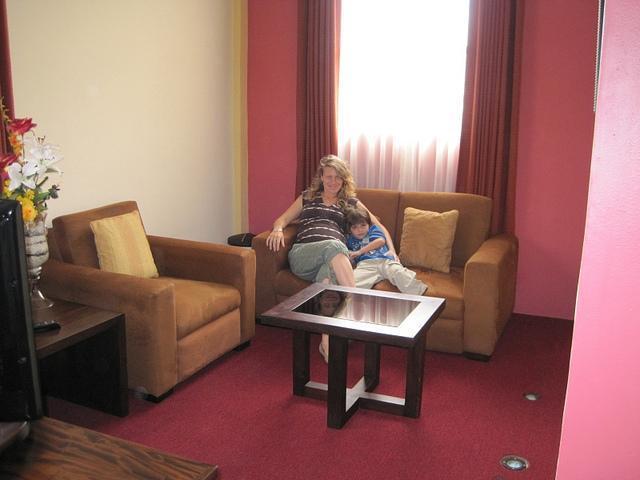How many rockers are in the picture?
Give a very brief answer. 0. How many chairs are at the table?
Give a very brief answer. 2. How many people can be seen?
Give a very brief answer. 2. How many cows are present?
Give a very brief answer. 0. 